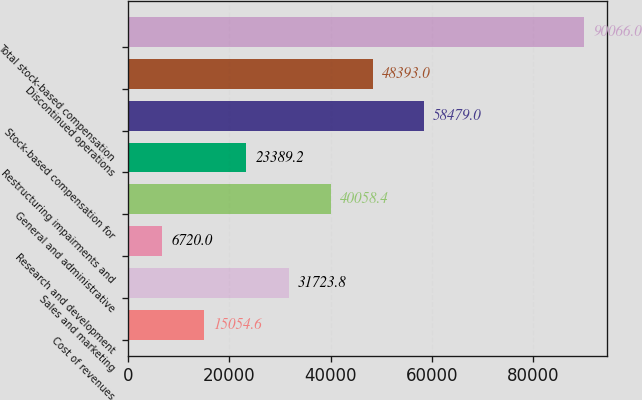Convert chart to OTSL. <chart><loc_0><loc_0><loc_500><loc_500><bar_chart><fcel>Cost of revenues<fcel>Sales and marketing<fcel>Research and development<fcel>General and administrative<fcel>Restructuring impairments and<fcel>Stock-based compensation for<fcel>Discontinued operations<fcel>Total stock-based compensation<nl><fcel>15054.6<fcel>31723.8<fcel>6720<fcel>40058.4<fcel>23389.2<fcel>58479<fcel>48393<fcel>90066<nl></chart> 